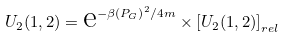Convert formula to latex. <formula><loc_0><loc_0><loc_500><loc_500>U _ { 2 } ( 1 , 2 ) = \text {e} ^ { - \beta \left ( { P } _ { G } \right ) ^ { 2 } / 4 m } \times \left [ U _ { 2 } ( 1 , 2 ) \right ] _ { r e l }</formula> 